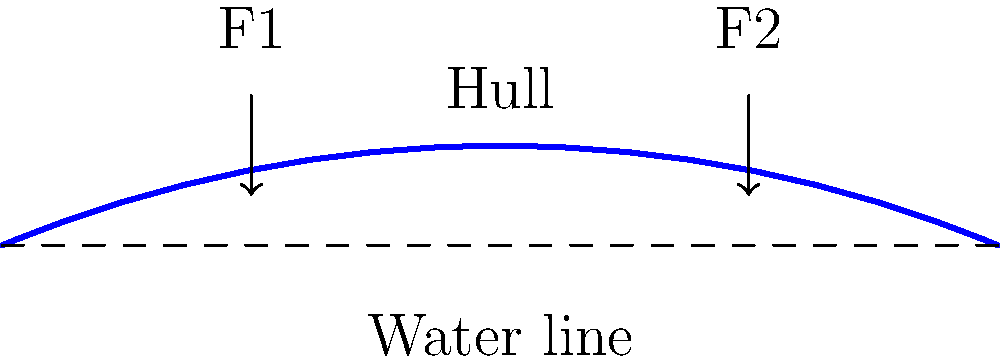During a slalom maneuver, a canoe experiences forces F1 and F2 as shown in the diagram. If F1 is 500N and F2 is 300N, what is the maximum bending moment experienced by the canoe hull, assuming it behaves like a simply supported beam of length 5m? To solve this problem, we'll follow these steps:

1. Treat the canoe hull as a simply supported beam with two point loads.
2. Calculate the reactions at the supports.
3. Determine the location of the maximum bending moment.
4. Calculate the maximum bending moment.

Step 1: The canoe hull is modeled as a 5m long beam with two point loads:
F1 = 500N at 1/4 of the length (1.25m)
F2 = 300N at 3/4 of the length (3.75m)

Step 2: Calculate reactions at the supports (RA and RB):
Sum of moments about A: $$R_B \cdot 5 - 500 \cdot 1.25 - 300 \cdot 3.75 = 0$$
$$R_B = \frac{500 \cdot 1.25 + 300 \cdot 3.75}{5} = 345N$$
$$R_A = 500 + 300 - 345 = 455N$$

Step 3: The maximum bending moment will occur either under one of the loads or at the point of zero shear force. We need to check all potential locations:

a) At F1 (x = 1.25m):
$$M_1 = R_A \cdot 1.25 = 455 \cdot 1.25 = 568.75 Nm$$

b) At F2 (x = 3.75m):
$$M_2 = R_A \cdot 3.75 - 500 \cdot 2.5 = 455 \cdot 3.75 - 500 \cdot 2.5 = 456.25 Nm$$

c) At zero shear force point:
Shear force is zero when $$R_A - 500 = 0$$, which occurs at x = 1.25m (same as F1)

Step 4: The maximum bending moment is the larger of M1 and M2:
$$M_{max} = max(568.75, 456.25) = 568.75 Nm$$

Therefore, the maximum bending moment experienced by the canoe hull during this slalom maneuver is 568.75 Nm.
Answer: 568.75 Nm 